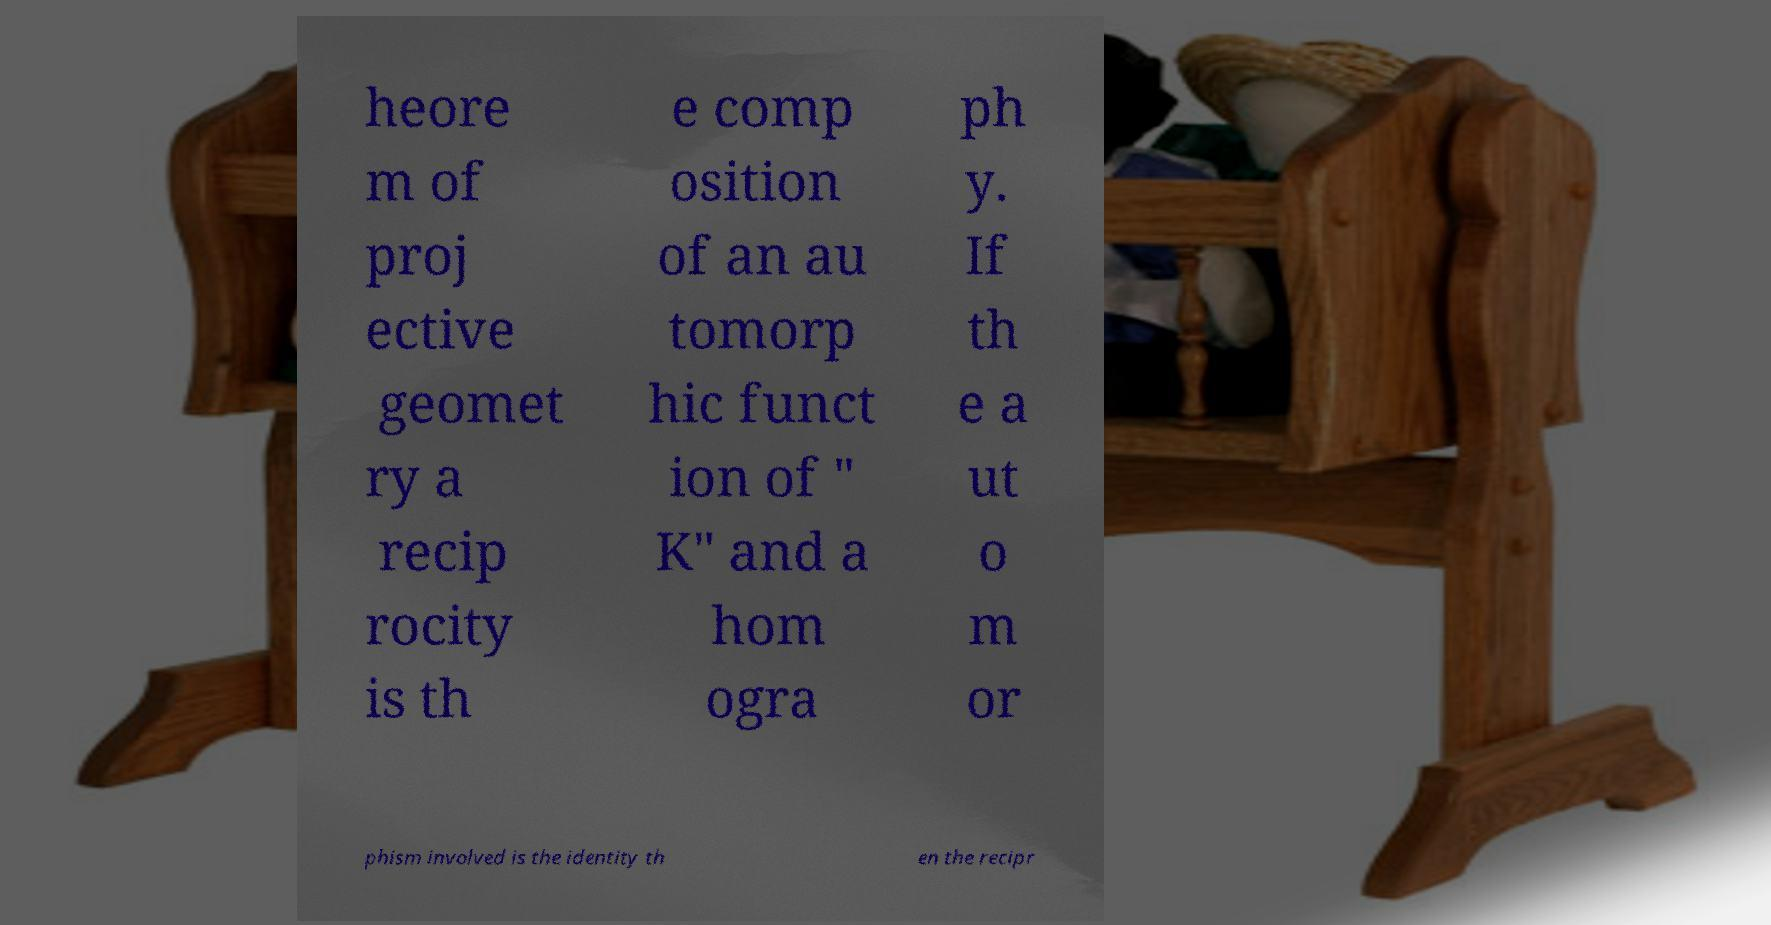Can you read and provide the text displayed in the image?This photo seems to have some interesting text. Can you extract and type it out for me? heore m of proj ective geomet ry a recip rocity is th e comp osition of an au tomorp hic funct ion of " K" and a hom ogra ph y. If th e a ut o m or phism involved is the identity th en the recipr 